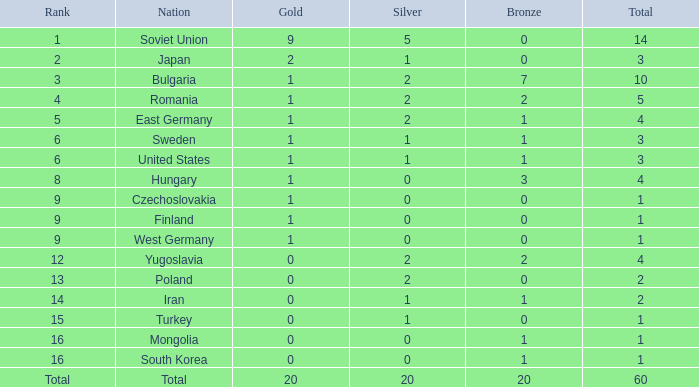What is the sum of golds for ranks of 6 and totals over 3? None. 